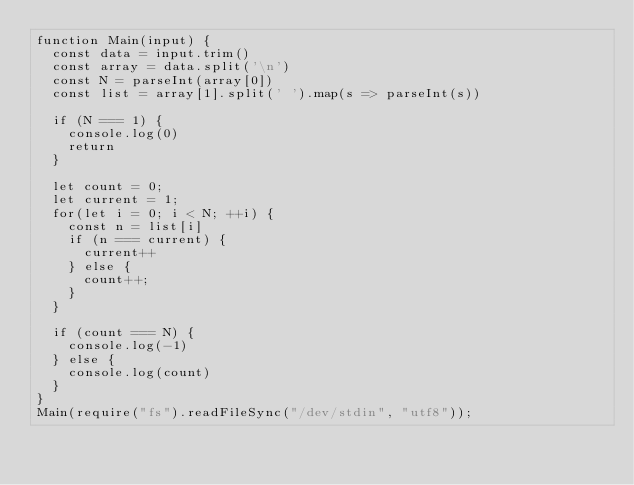Convert code to text. <code><loc_0><loc_0><loc_500><loc_500><_JavaScript_>function Main(input) {
  const data = input.trim()
  const array = data.split('\n')
  const N = parseInt(array[0])
  const list = array[1].split(' ').map(s => parseInt(s))

  if (N === 1) {
    console.log(0)
    return
  }

  let count = 0;
  let current = 1;
  for(let i = 0; i < N; ++i) {
    const n = list[i]
    if (n === current) {
      current++
    } else {
      count++;
    }
  }
  
  if (count === N) {
    console.log(-1)
  } else {
    console.log(count)
  }
}
Main(require("fs").readFileSync("/dev/stdin", "utf8"));</code> 